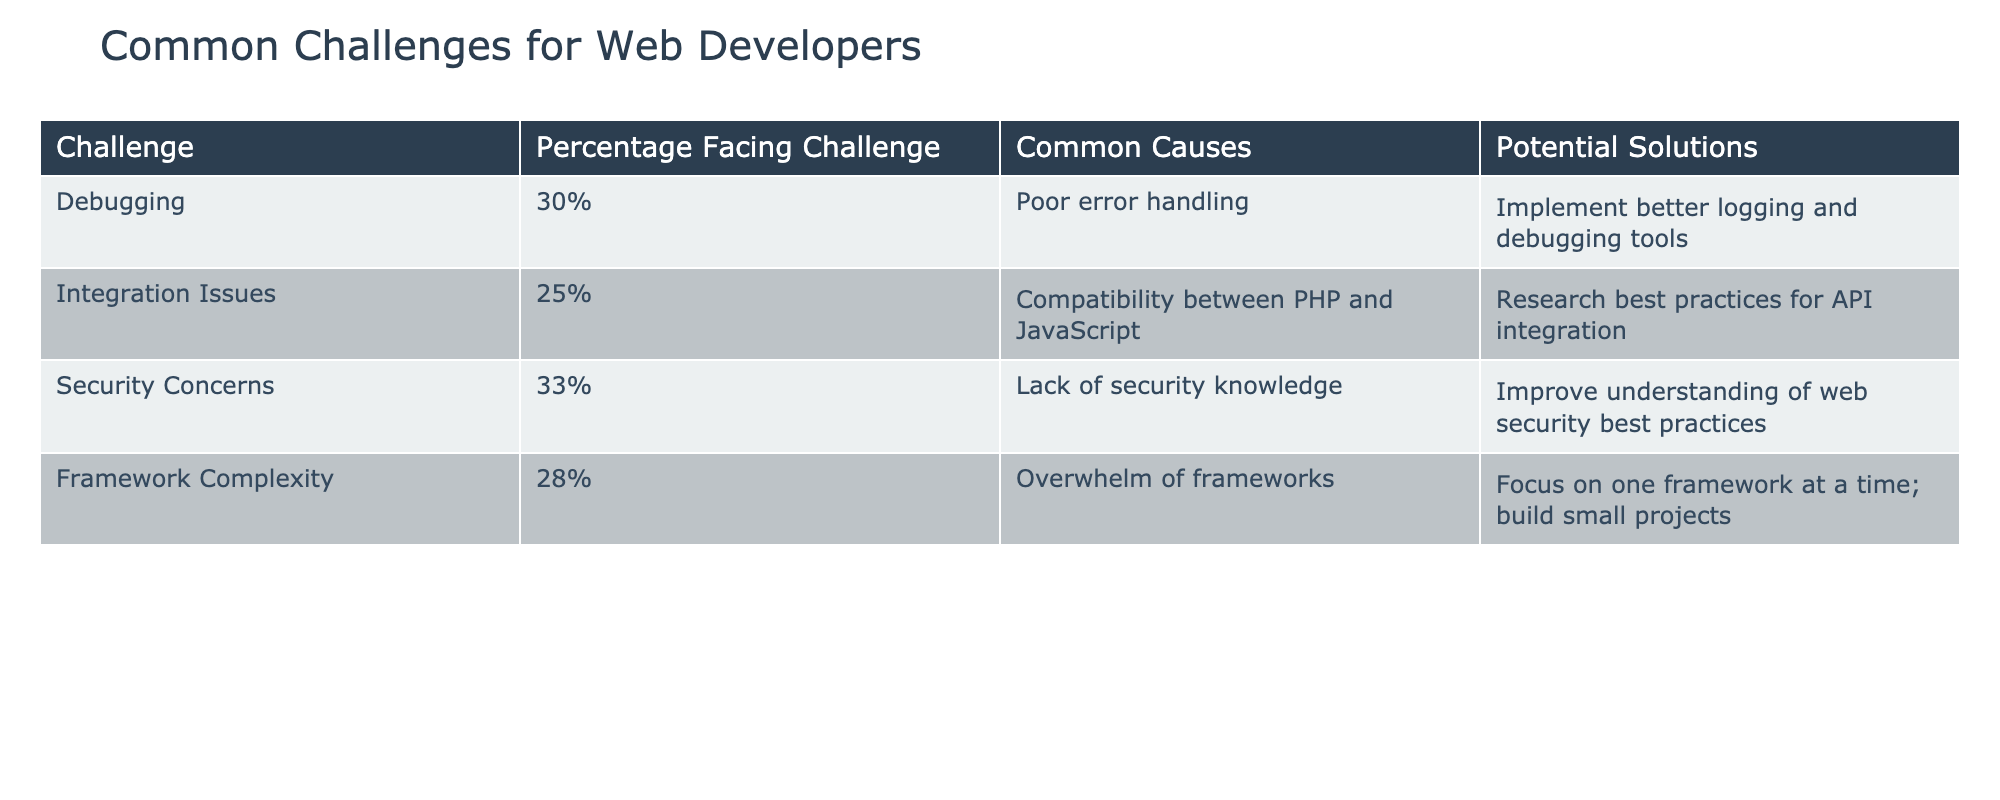What is the most common challenge faced by web developers according to the table? The table lists various challenges and their percentages. The challenge with the highest percentage is "Security Concerns" at 33%.
Answer: Security Concerns What percentage of developers face "Integration Issues"? The table clearly states that 25% of developers face "Integration Issues."
Answer: 25% Is "Debugging" a common challenge among web developers? Yes, according to the table, 30% of developers face "Debugging" challenges, which indicates it is a common issue.
Answer: Yes What is the average percentage of web developers facing "Framework Complexity" and "Integration Issues"? The percentages for "Framework Complexity" (28%) and "Integration Issues" (25%) add up to 53%. To find the average, divide by 2, so 53%/2 = 26.5%.
Answer: 26.5% Are more developers facing "Security Concerns" than "Debugging" challenges? Yes, "Security Concerns" has a percentage of 33%, which is greater than the 30% facing "Debugging," indicating that more developers face security challenges.
Answer: Yes Which challenge has the lowest percentage and what are its common causes? The challenge with the lowest percentage is "Integration Issues" at 25%, caused by compatibility issues between PHP and JavaScript.
Answer: Integration Issues; Compatibility between PHP and JavaScript If a developer wanted to improve their skills in 'Integrating Issues', what solution is suggested in the table? The table suggests that developers research best practices for API integration to solve "Integration Issues."
Answer: Research best practices for API integration What are the common causes of the challenge "Framework Complexity"? The common cause for "Framework Complexity" is being overwhelmed by the variety of frameworks available.
Answer: Overwhelm of frameworks What percentage of developers face both "Debugging" and "Framework Complexity" challenges? By looking at the percentages from the table, 30% face "Debugging" and 28% face "Framework Complexity." While the question is about the number of developers facing both, as per the table, we note that individuals can face multiple challenges, but we cannot sum them directly.
Answer: Not directly answerable; individuals can face multiple challenges 